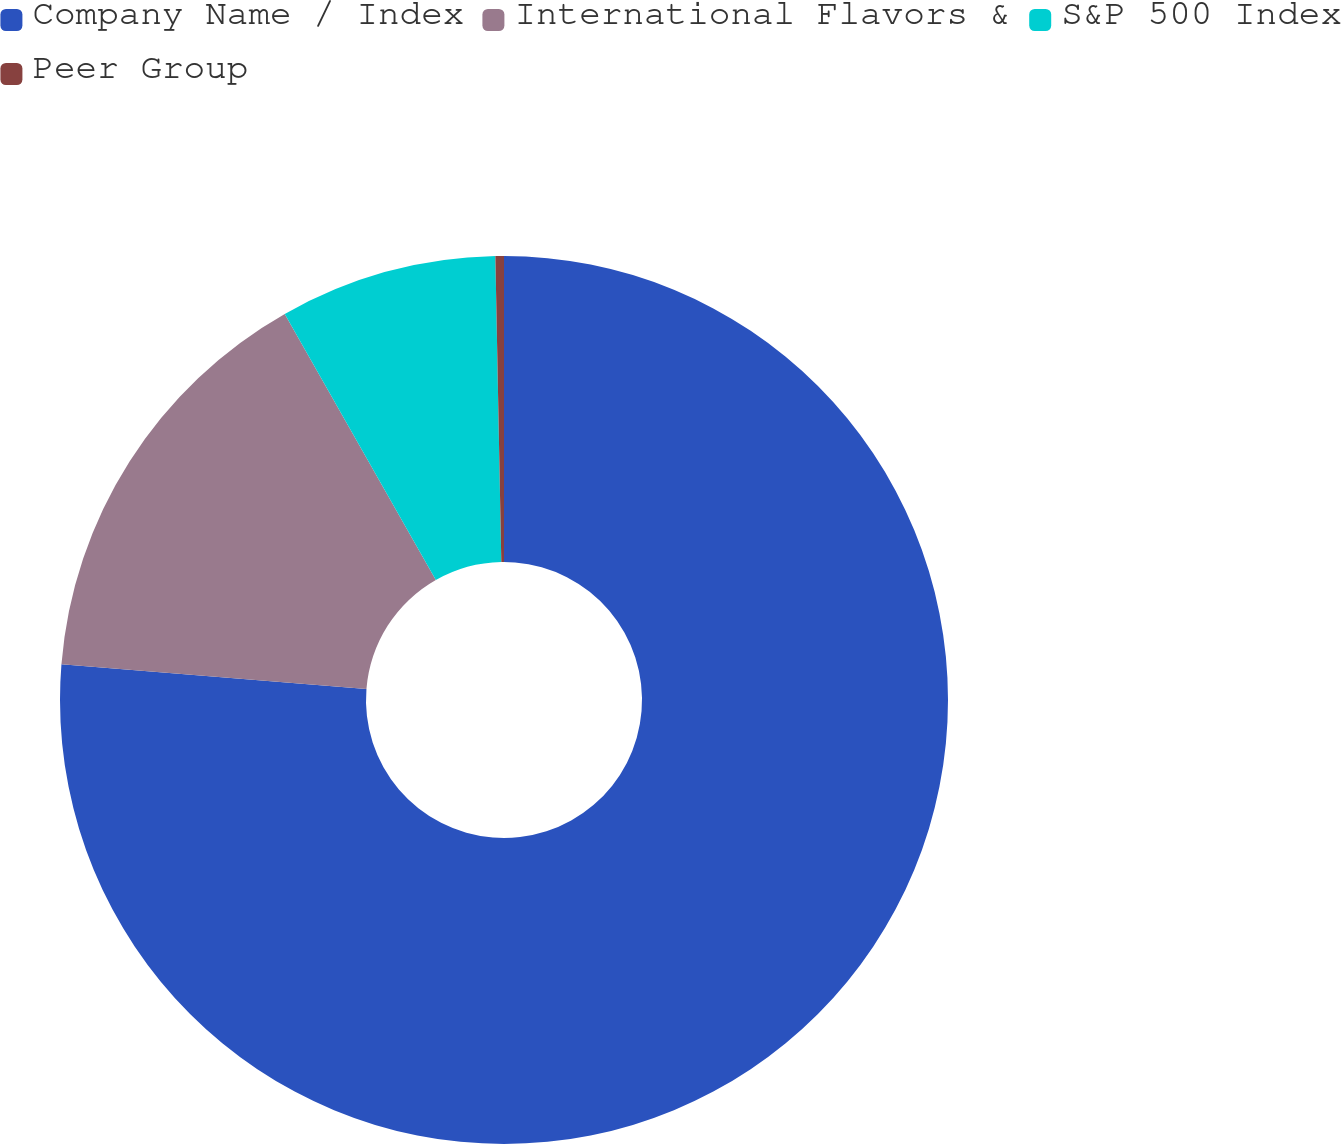<chart> <loc_0><loc_0><loc_500><loc_500><pie_chart><fcel>Company Name / Index<fcel>International Flavors &<fcel>S&P 500 Index<fcel>Peer Group<nl><fcel>76.28%<fcel>15.5%<fcel>7.91%<fcel>0.31%<nl></chart> 